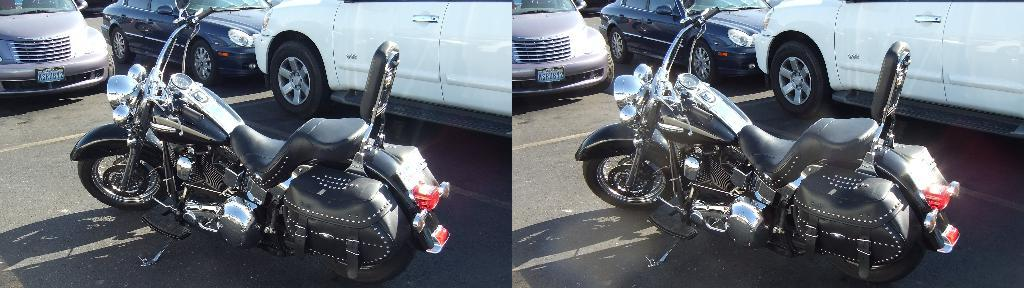What type of vehicle is present in the image? There is a bike in the image. What other types of vehicles can be seen in the image? There are cars in the image. Where are the cars located in the image? The cars are at the top side of the image. What type of location might the image represent? The image appears to be of a college. What type of sheet is covering the bike in the image? There is no sheet covering the bike in the image. How does the death of a student affect the college in the image? There is no indication of a student's death in the image, so it cannot be determined how it would affect the college. 